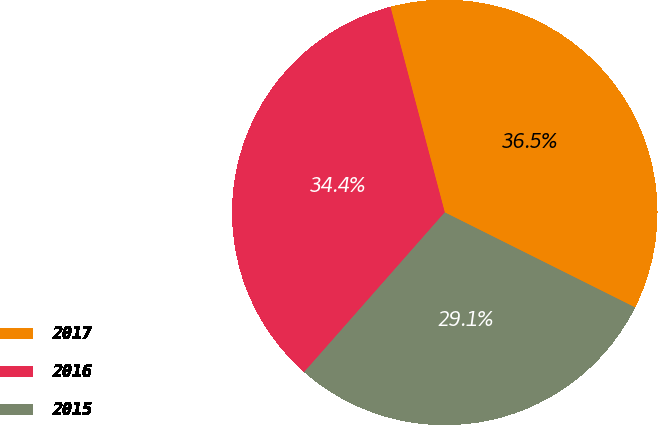<chart> <loc_0><loc_0><loc_500><loc_500><pie_chart><fcel>2017<fcel>2016<fcel>2015<nl><fcel>36.49%<fcel>34.39%<fcel>29.12%<nl></chart> 